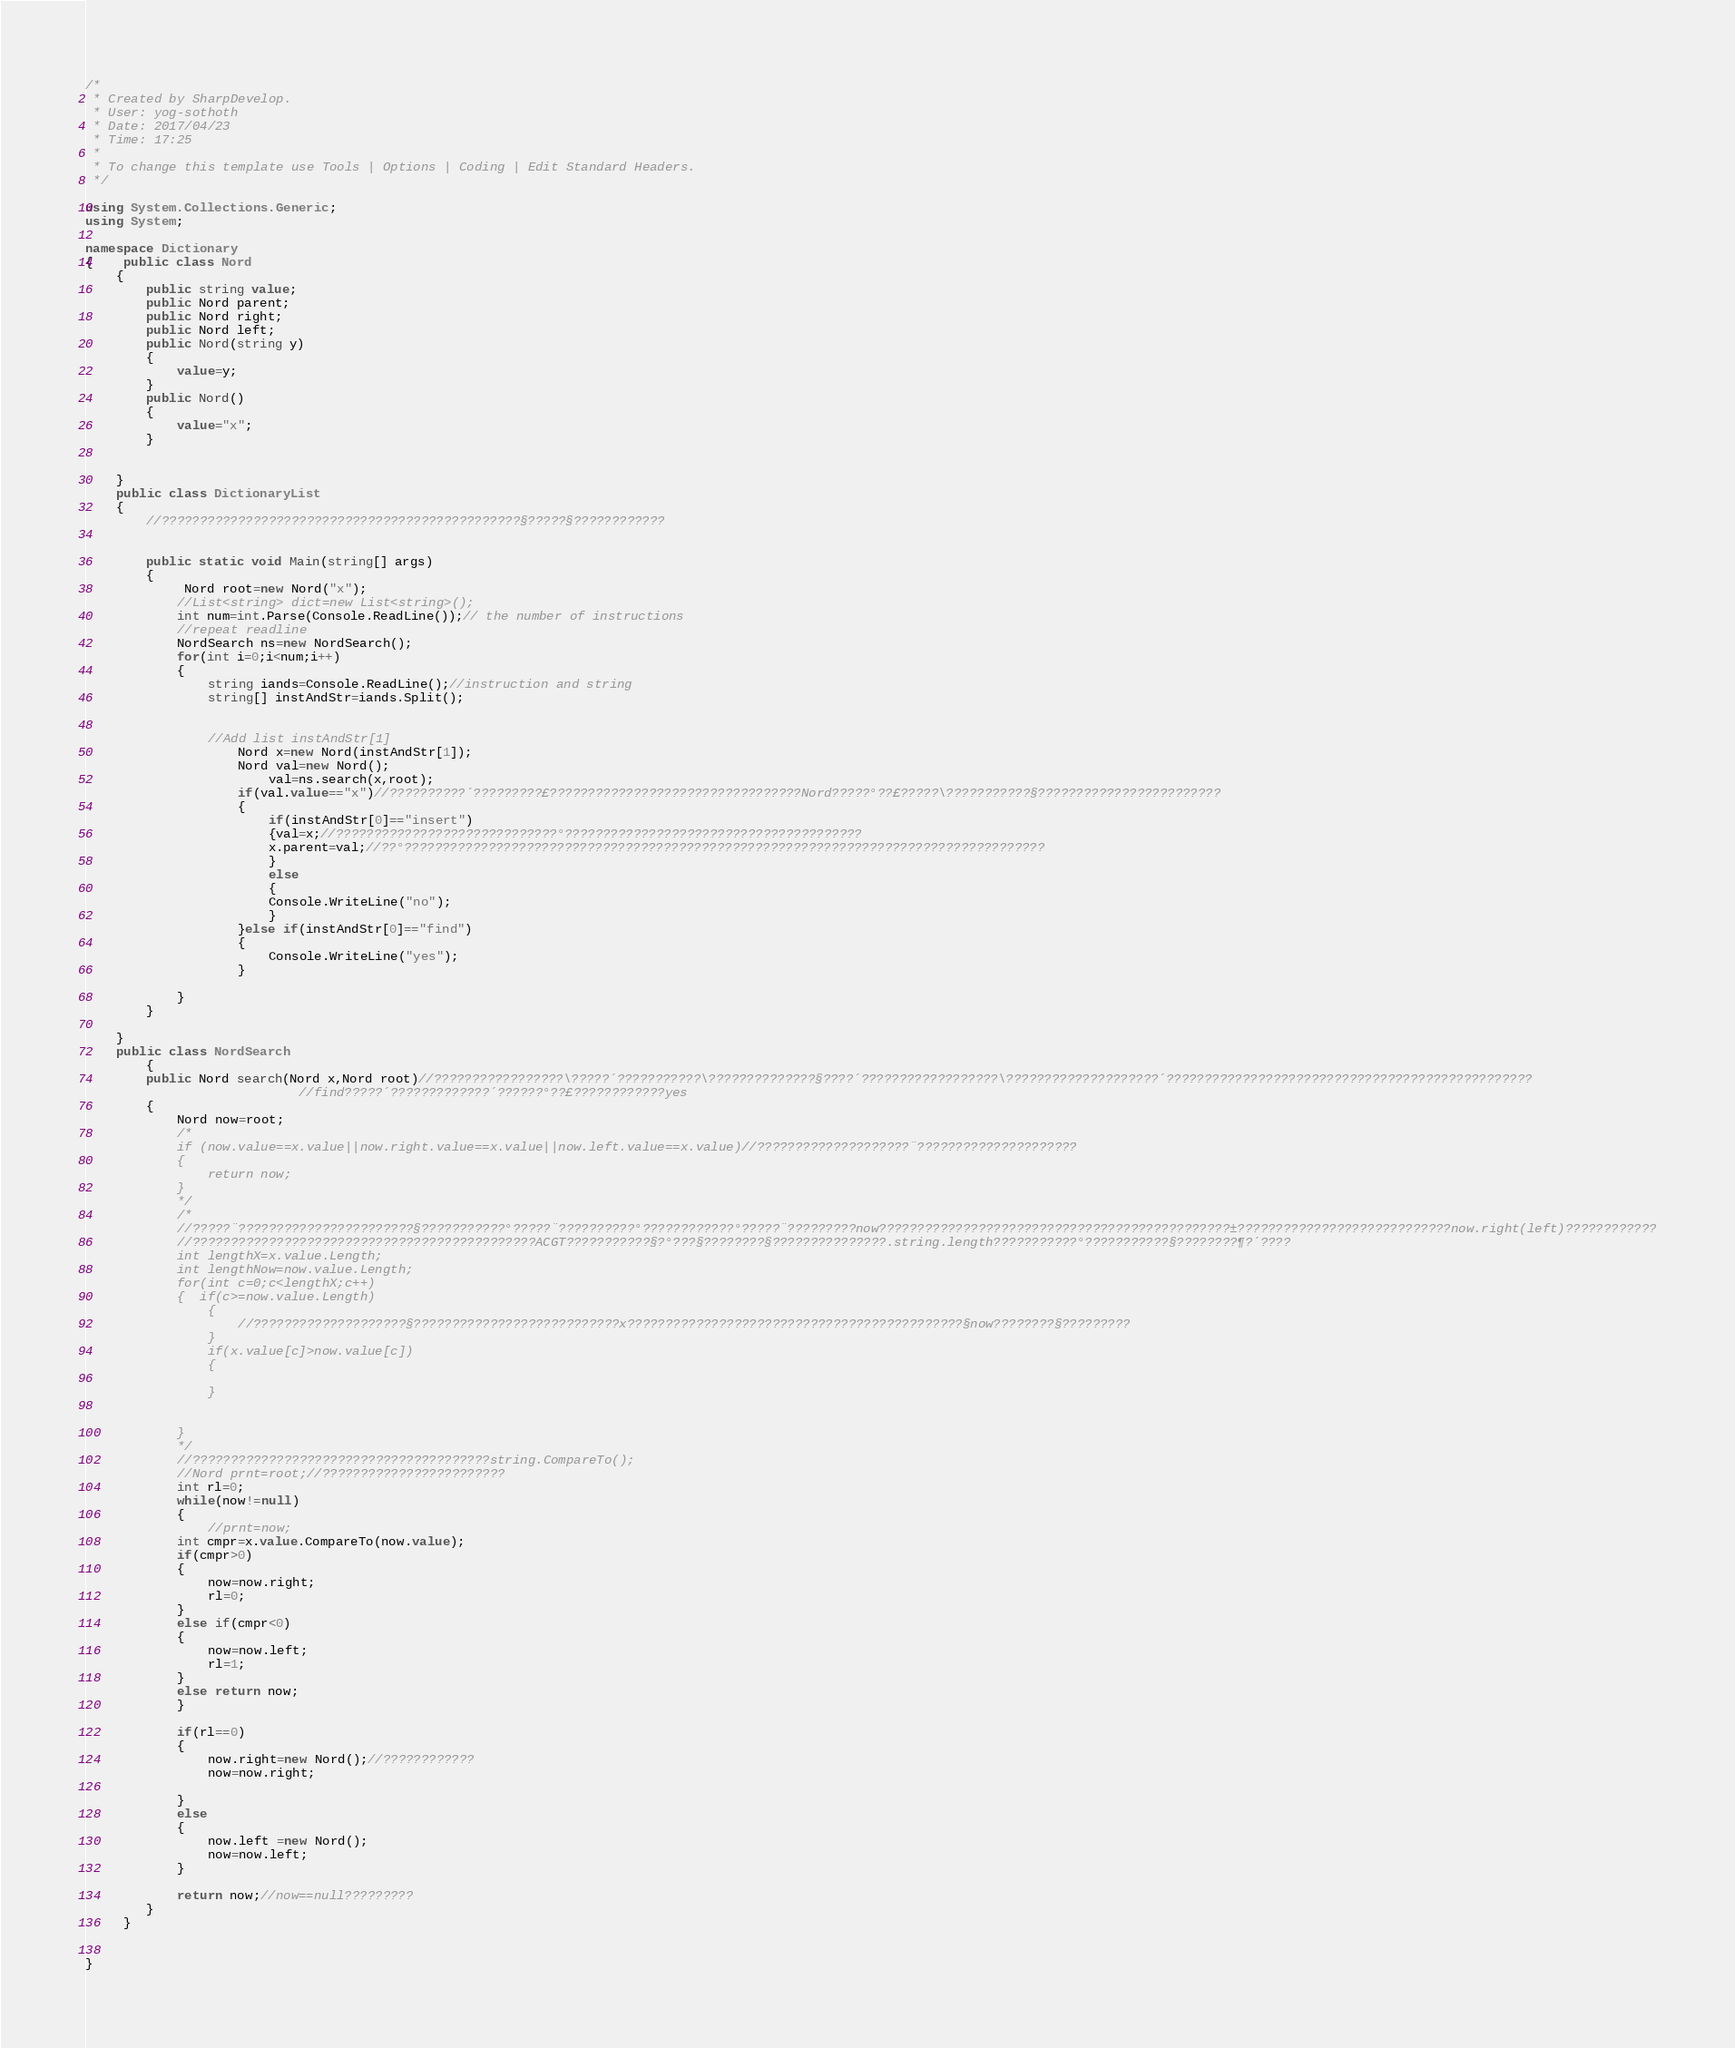<code> <loc_0><loc_0><loc_500><loc_500><_C#_>/*
 * Created by SharpDevelop.
 * User: yog-sothoth
 * Date: 2017/04/23
 * Time: 17:25
 * 
 * To change this template use Tools | Options | Coding | Edit Standard Headers.
 */

using System.Collections.Generic;
using System;

namespace Dictionary
{	public class Nord
	{
		public string value;
		public Nord parent;
		public Nord right;
		public Nord left;
		public Nord(string y)
		{
			value=y;
		}
		public Nord()
		{
			value="x";
		}
		
		
	}
	public class DictionaryList
	{
		//???????????????????????????????????????????????§?????§????????????
		
		
		public static void Main(string[] args)
		{
			 Nord root=new Nord("x");
			//List<string> dict=new List<string>();
			int num=int.Parse(Console.ReadLine());// the number of instructions
			//repeat readline
			NordSearch ns=new NordSearch();
			for(int i=0;i<num;i++)
			{
				string iands=Console.ReadLine();//instruction and string
				string[] instAndStr=iands.Split();
				
				
				//Add list instAndStr[1]
					Nord x=new Nord(instAndStr[1]);
					Nord val=new Nord();
						val=ns.search(x,root);
					if(val.value=="x")//??????????´?????????£?????????????????????????????????Nord?????°??£?????\???????????§????????????????????????
					{ 
						if(instAndStr[0]=="insert")
						{val=x;//?????????????????????????????°???????????????????????????????????????
						x.parent=val;//??°????????????????????????????????????????????????????????????????????????????????????
						}
						else 
						{
						Console.WriteLine("no");
						}
					}else if(instAndStr[0]=="find")
					{
						Console.WriteLine("yes");
					}		
				
			}			
		}
		
	}
	public class NordSearch
		{
		public Nord search(Nord x,Nord root)//?????????????????\?????´???????????\??????????????§????´??????????????????\????????????????????´????????????????????????????????????????????????
							//find?????´?????????????´??????°??£????????????yes
		{
			Nord now=root;
			/*
			if (now.value==x.value||now.right.value==x.value||now.left.value==x.value)//????????????????????¨?????????????????????
			{
				return now;
			}
			*/
			/*
			//?????¨???????????????????????§???????????°?????¨??????????°????????????°?????¨?????????now??????????????????????????????????????????????±????????????????????????????now.right(left)????????????
			//?????????????????????????????????????????????ACGT???????????§?°???§????????§???????????????.string.length???????????°???????????§????????¶?´????			
			int lengthX=x.value.Length;
			int lengthNow=now.value.Length;
			for(int c=0;c<lengthX;c++)
			{  if(c>=now.value.Length)
				{
					//????????????????????§???????????????????????????x????????????????????????????????????????????§now????????§?????????
				}
				if(x.value[c]>now.value[c])
				{
				
				}
				
			
			}
			*/
			//???????????????????????????????????????string.CompareTo();
			//Nord prnt=root;//????????????????????????
			int rl=0;
			while(now!=null)
			{
				//prnt=now;
			int cmpr=x.value.CompareTo(now.value);
			if(cmpr>0)
			{
				now=now.right;
				rl=0;
			}
			else if(cmpr<0)
			{
				now=now.left;
				rl=1;
			}
			else return now;
			}
			
			if(rl==0)
			{
				now.right=new Nord();//????????????
				now=now.right;
				
			}
			else 
			{
				now.left =new Nord();
				now=now.left;
			}
			
			return now;//now==null?????????
		}
	 }


}</code> 